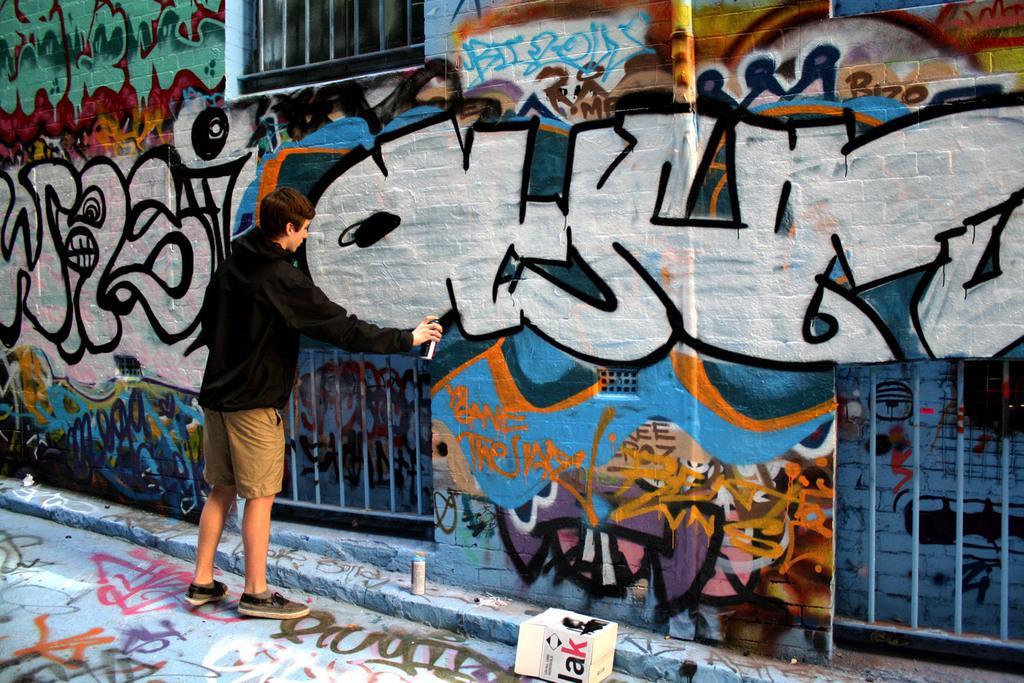Who is present in the image? There is a boy in the image. What is the boy holding in the image? The boy is holding a spray in the image. What can be seen behind the boy? There is a wall in the image, and it is full of paintings. What type of muscle is being exercised by the boy in the image? There is no indication in the image that the boy is exercising any muscles, as he is holding a spray and standing in front of a wall full of paintings. 